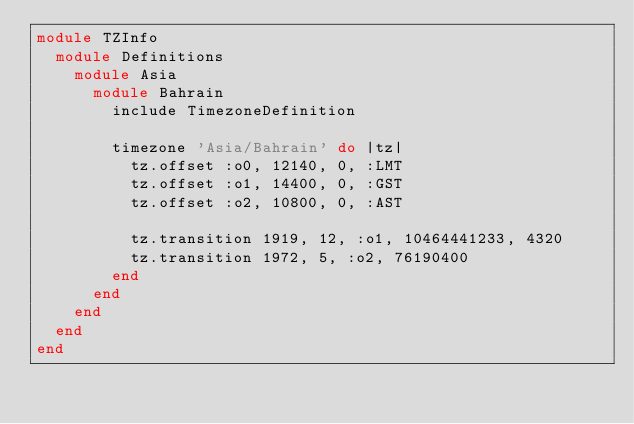Convert code to text. <code><loc_0><loc_0><loc_500><loc_500><_Ruby_>module TZInfo
  module Definitions
    module Asia
      module Bahrain
        include TimezoneDefinition
        
        timezone 'Asia/Bahrain' do |tz|
          tz.offset :o0, 12140, 0, :LMT
          tz.offset :o1, 14400, 0, :GST
          tz.offset :o2, 10800, 0, :AST
          
          tz.transition 1919, 12, :o1, 10464441233, 4320
          tz.transition 1972, 5, :o2, 76190400
        end
      end
    end
  end
end
</code> 